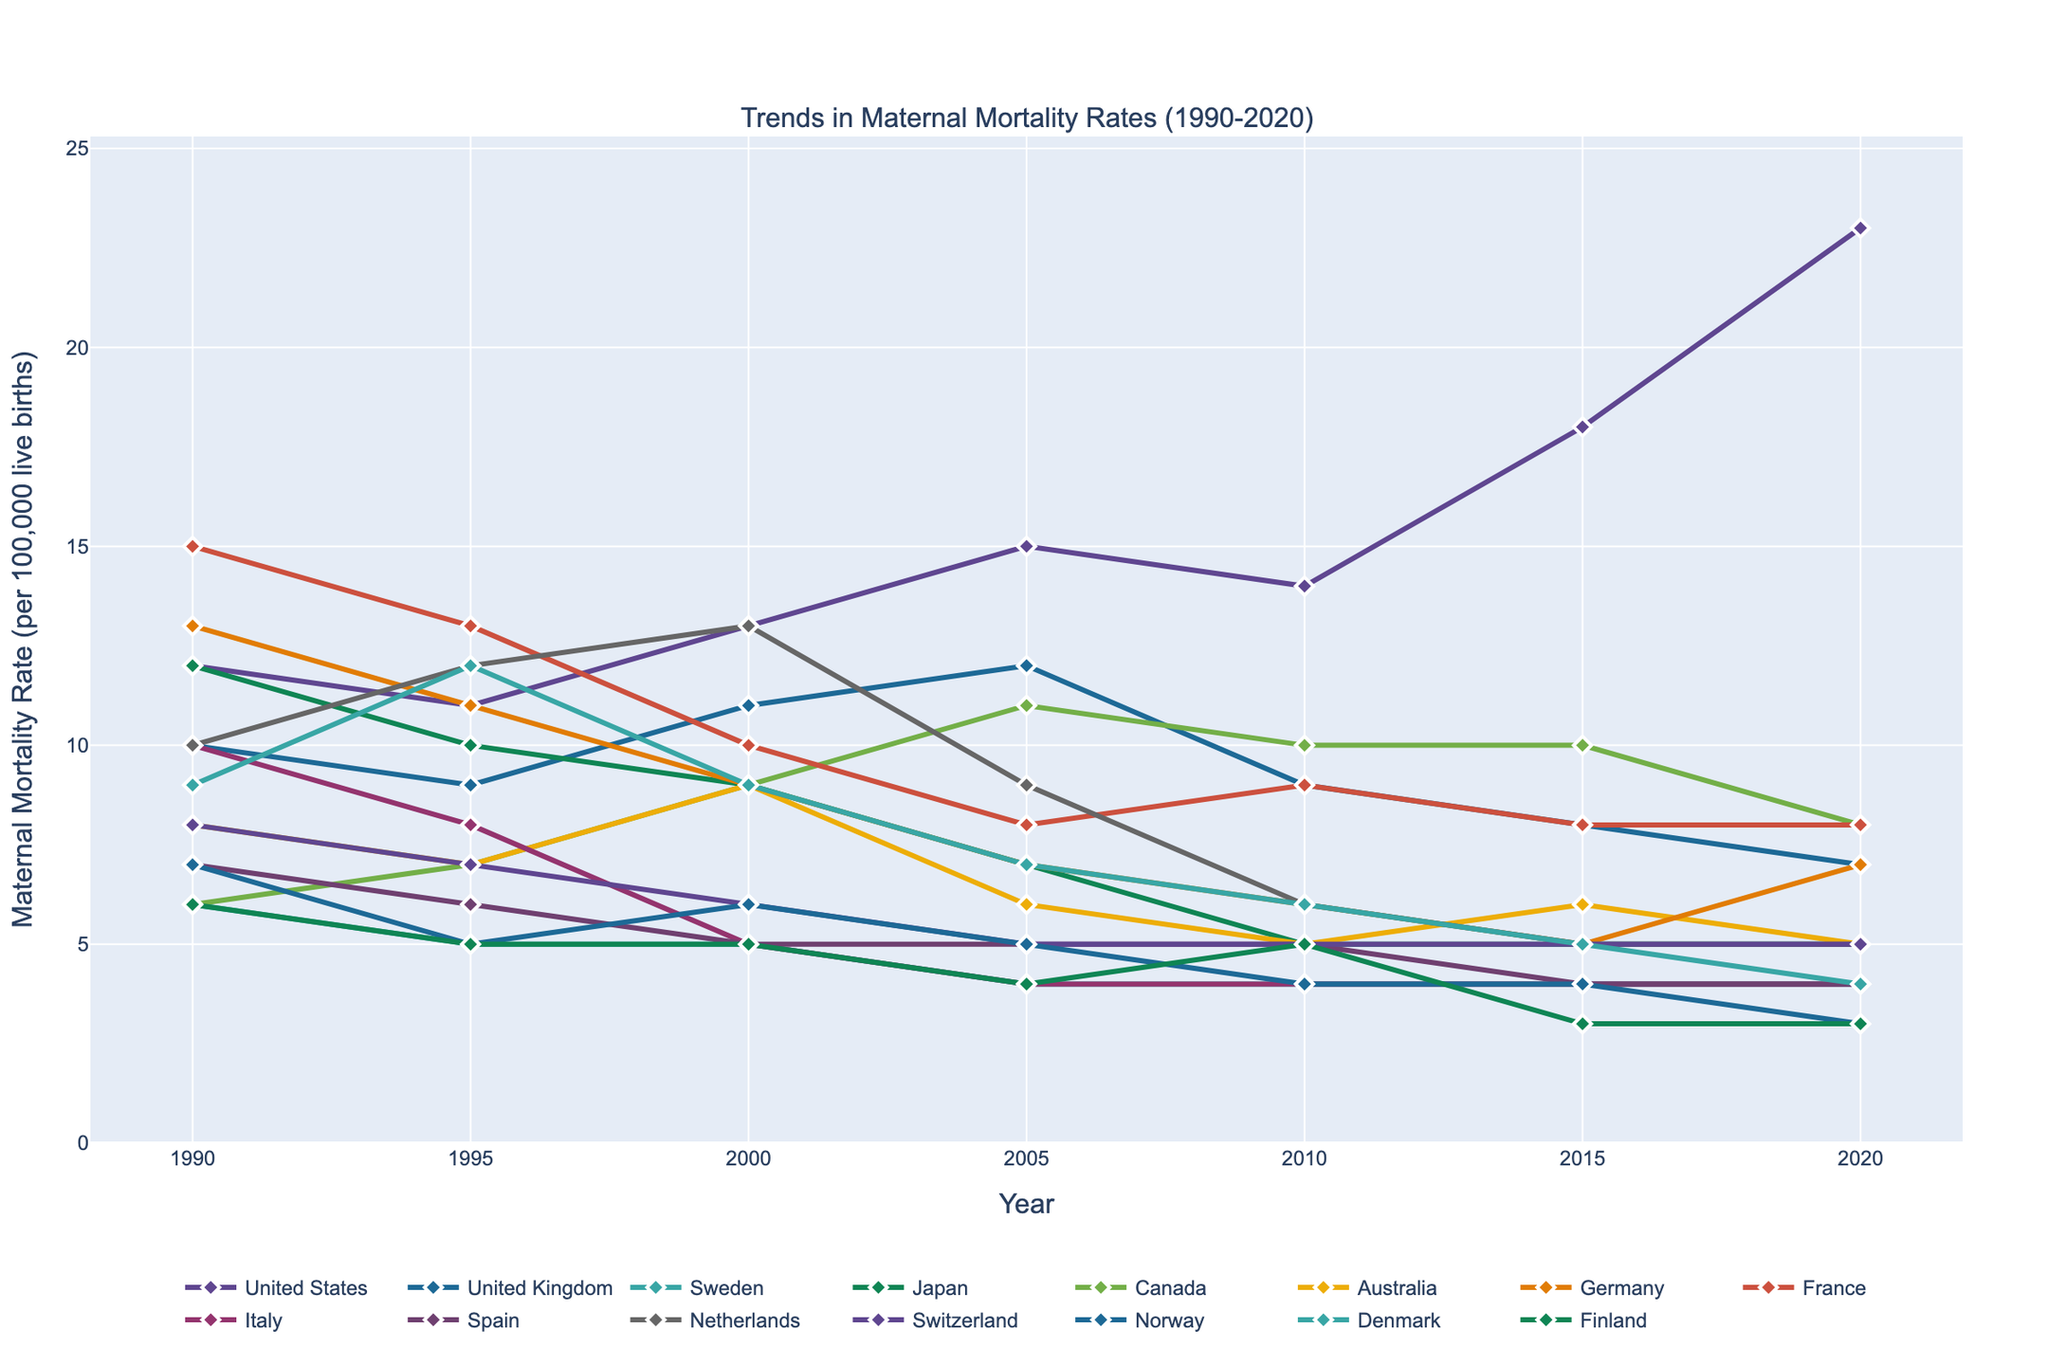What's the trend in maternal mortality rates in the United States from 1990 to 2020? The maternal mortality rate in the United States starts at 12 in 1990 and steadily increases to 23 by 2020, showing a general upward trend.
Answer: Upward trend Which country had the lowest maternal mortality rate in 2020? By examining the y-values for the year 2020 across all the countries, Norway and Finland have the lowest rate, both at 3.
Answer: Norway and Finland How does the trend in maternal mortality rates in the United Kingdom compare to the United States? The maternal mortality rate in the United Kingdom generally decreases from 10 in 1990 to 7 in 2020, while in the United States it increases from 12 in 1990 to 23 in 2020.
Answer: UK: Downward, US: Upward What is the average maternal mortality rate in Sweden over the 30 years? Summing the rates in Sweden between 1990 and 2020 (6 + 5 + 5 + 4 + 4 + 4 + 4) equals 32. Dividing by the number of intervals (7), we get approximately 4.57.
Answer: 4.57 Which country has shown the most significant decline in maternal mortality rates from 1990 to 2020? Comparing the drop in rates from 1990 to 2020 for each country, Germany shows a significant decline from 13 to 7, a difference of 6.
Answer: Germany Which countries had a maternal mortality rate below 5 in 2020? Examining the 2020 rate values, countries with rates below 5 include Sweden, Japan, Australia, Italy, Spain, Switzerland, Norway, Denmark, and Finland.
Answer: Nine Between which years did France experience the highest rate of decline in maternal mortality rates? Observing the changes for France, the highest decline occurred between 1990 (15) and 2005 (8), which reflects a drop of 7.
Answer: 1990-2005 How many countries had a constant maternal mortality rate from 2010 to 2020? By examining each country's rates visually, Sweden, Italy, Spain, Switzerland, and Japan maintained constant rates from 2010 to 2020.
Answer: Five How does the maternal mortality rate trend in Canada compare to Australia between 1990 and 2020? In Canada, the rate shows slight fluctuations, especially between 1990 (6) to 2010 (10), and a decline to 8 in 2020. In Australia, it declines overall from 1990 (8) to 2020 (5) but shows fluctuations around 2000 and 2015.
Answer: Canada: Fluctuating Upward, Australia: Fluctuating Downward 